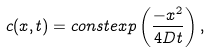<formula> <loc_0><loc_0><loc_500><loc_500>c ( x , t ) = c o n s t e x p \left ( \frac { - x ^ { 2 } } { 4 D t } \right ) ,</formula> 